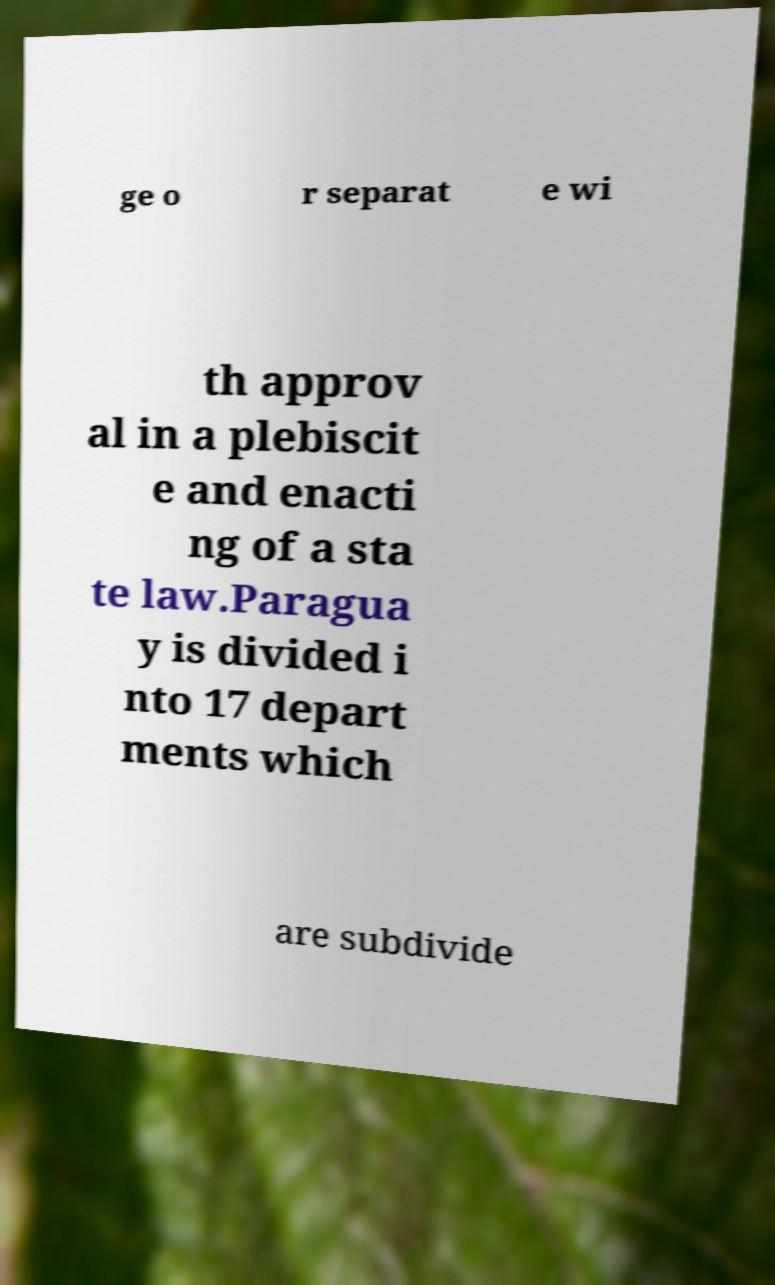There's text embedded in this image that I need extracted. Can you transcribe it verbatim? ge o r separat e wi th approv al in a plebiscit e and enacti ng of a sta te law.Paragua y is divided i nto 17 depart ments which are subdivide 